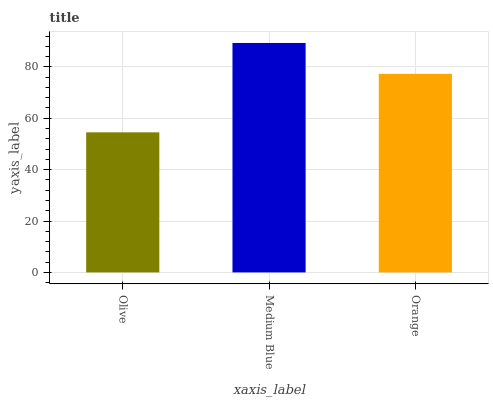Is Olive the minimum?
Answer yes or no. Yes. Is Medium Blue the maximum?
Answer yes or no. Yes. Is Orange the minimum?
Answer yes or no. No. Is Orange the maximum?
Answer yes or no. No. Is Medium Blue greater than Orange?
Answer yes or no. Yes. Is Orange less than Medium Blue?
Answer yes or no. Yes. Is Orange greater than Medium Blue?
Answer yes or no. No. Is Medium Blue less than Orange?
Answer yes or no. No. Is Orange the high median?
Answer yes or no. Yes. Is Orange the low median?
Answer yes or no. Yes. Is Medium Blue the high median?
Answer yes or no. No. Is Olive the low median?
Answer yes or no. No. 